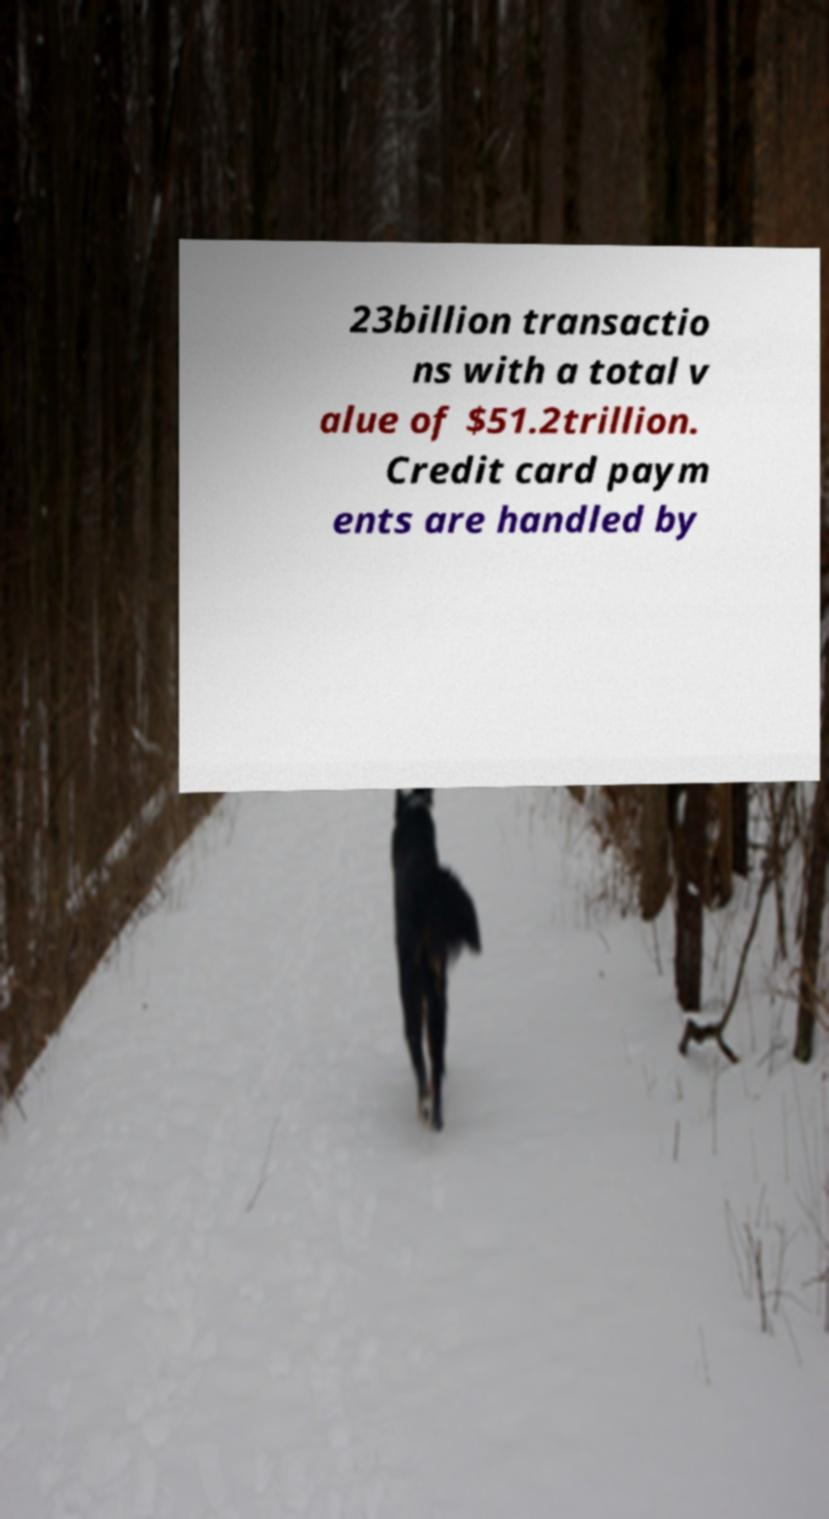I need the written content from this picture converted into text. Can you do that? 23billion transactio ns with a total v alue of $51.2trillion. Credit card paym ents are handled by 